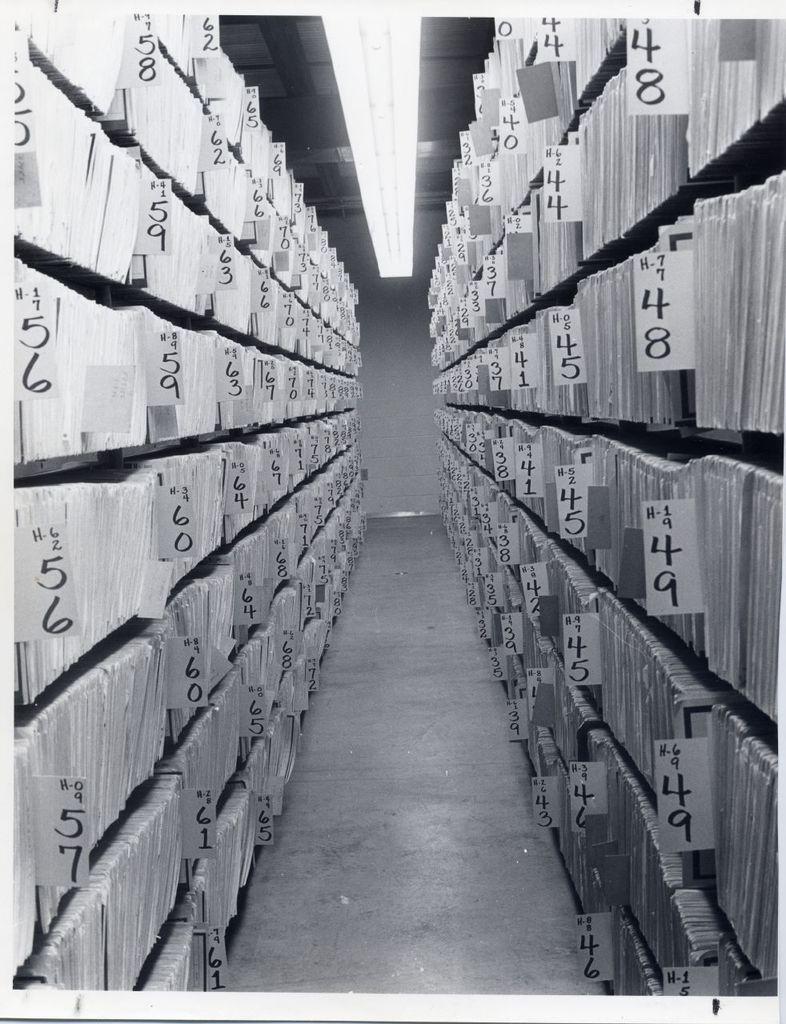Could you give a brief overview of what you see in this image? In this picture there are papers with some numbers written on it and on the top there is a light. 